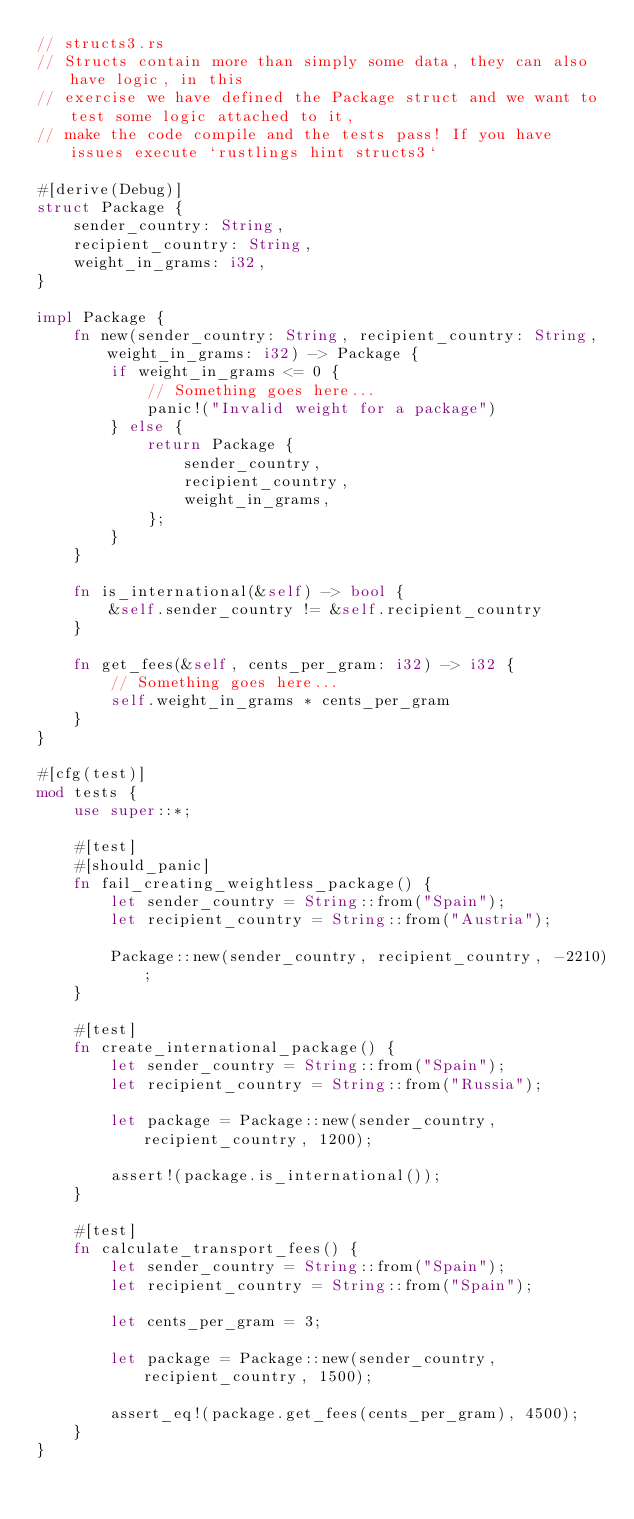<code> <loc_0><loc_0><loc_500><loc_500><_Rust_>// structs3.rs
// Structs contain more than simply some data, they can also have logic, in this
// exercise we have defined the Package struct and we want to test some logic attached to it,
// make the code compile and the tests pass! If you have issues execute `rustlings hint structs3`

#[derive(Debug)]
struct Package {
    sender_country: String,
    recipient_country: String,
    weight_in_grams: i32,
}

impl Package {
    fn new(sender_country: String, recipient_country: String, weight_in_grams: i32) -> Package {
        if weight_in_grams <= 0 {
            // Something goes here...
            panic!("Invalid weight for a package")
        } else {
            return Package {
                sender_country,
                recipient_country,
                weight_in_grams,
            };
        }
    }

    fn is_international(&self) -> bool {
        &self.sender_country != &self.recipient_country
    }

    fn get_fees(&self, cents_per_gram: i32) -> i32 {
        // Something goes here... 
        self.weight_in_grams * cents_per_gram
    }
}

#[cfg(test)]
mod tests {
    use super::*;

    #[test]
    #[should_panic]
    fn fail_creating_weightless_package() {
        let sender_country = String::from("Spain");
        let recipient_country = String::from("Austria");

        Package::new(sender_country, recipient_country, -2210);
    }

    #[test]
    fn create_international_package() {
        let sender_country = String::from("Spain");
        let recipient_country = String::from("Russia");

        let package = Package::new(sender_country, recipient_country, 1200);

        assert!(package.is_international());
    }

    #[test]
    fn calculate_transport_fees() {
        let sender_country = String::from("Spain");
        let recipient_country = String::from("Spain");

        let cents_per_gram = 3;

        let package = Package::new(sender_country, recipient_country, 1500);

        assert_eq!(package.get_fees(cents_per_gram), 4500);
    }
}
</code> 